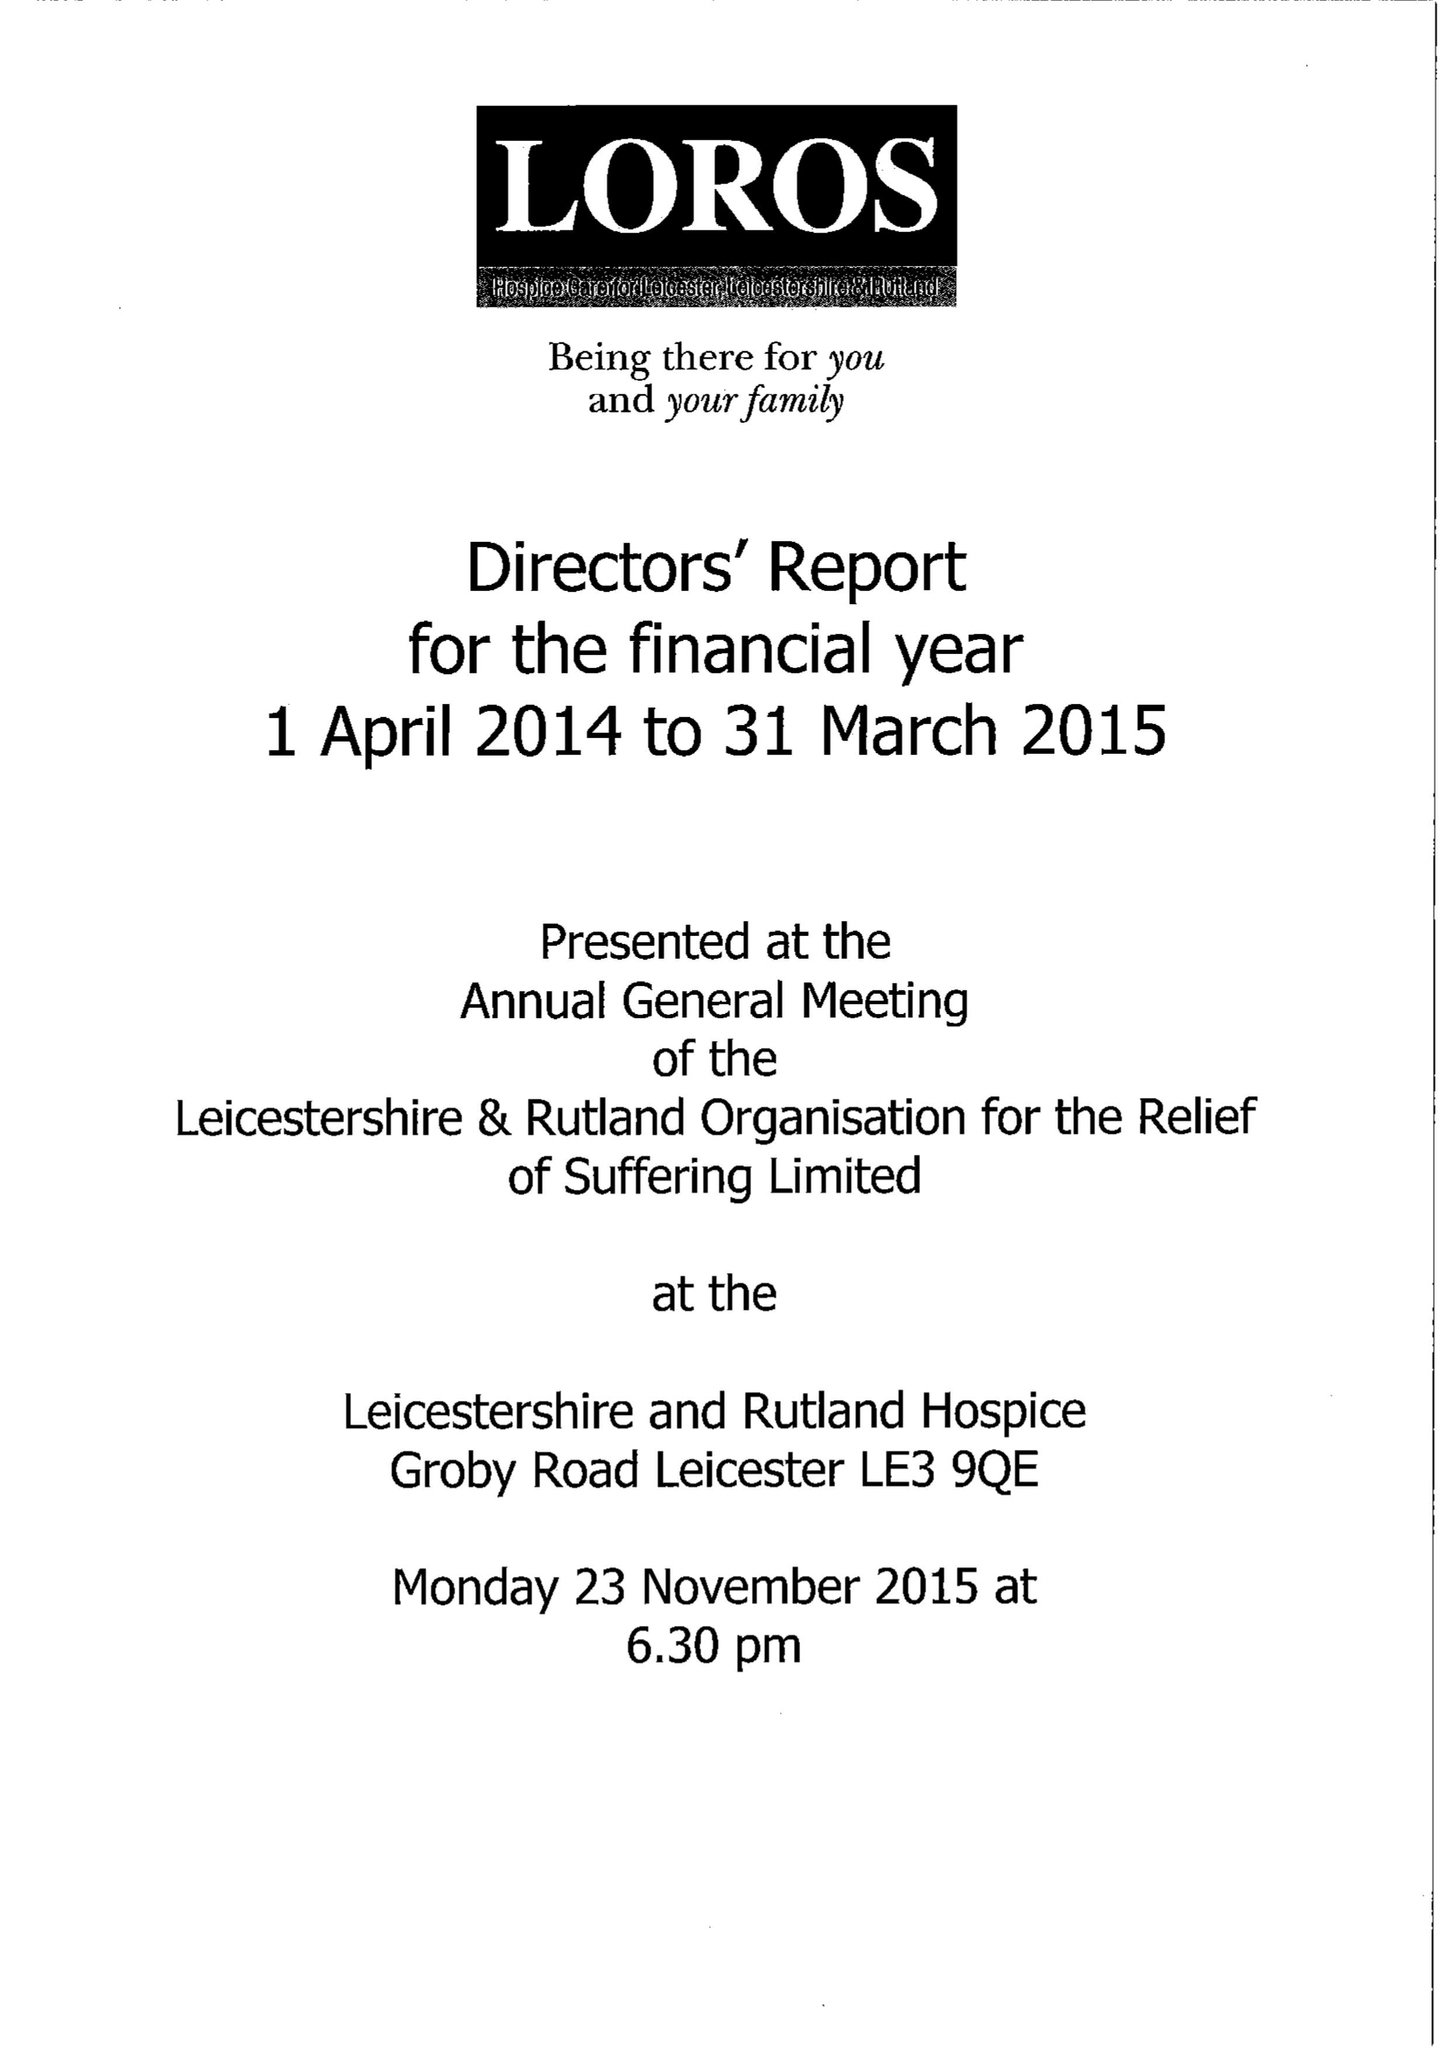What is the value for the address__postcode?
Answer the question using a single word or phrase. LE3 9QE 